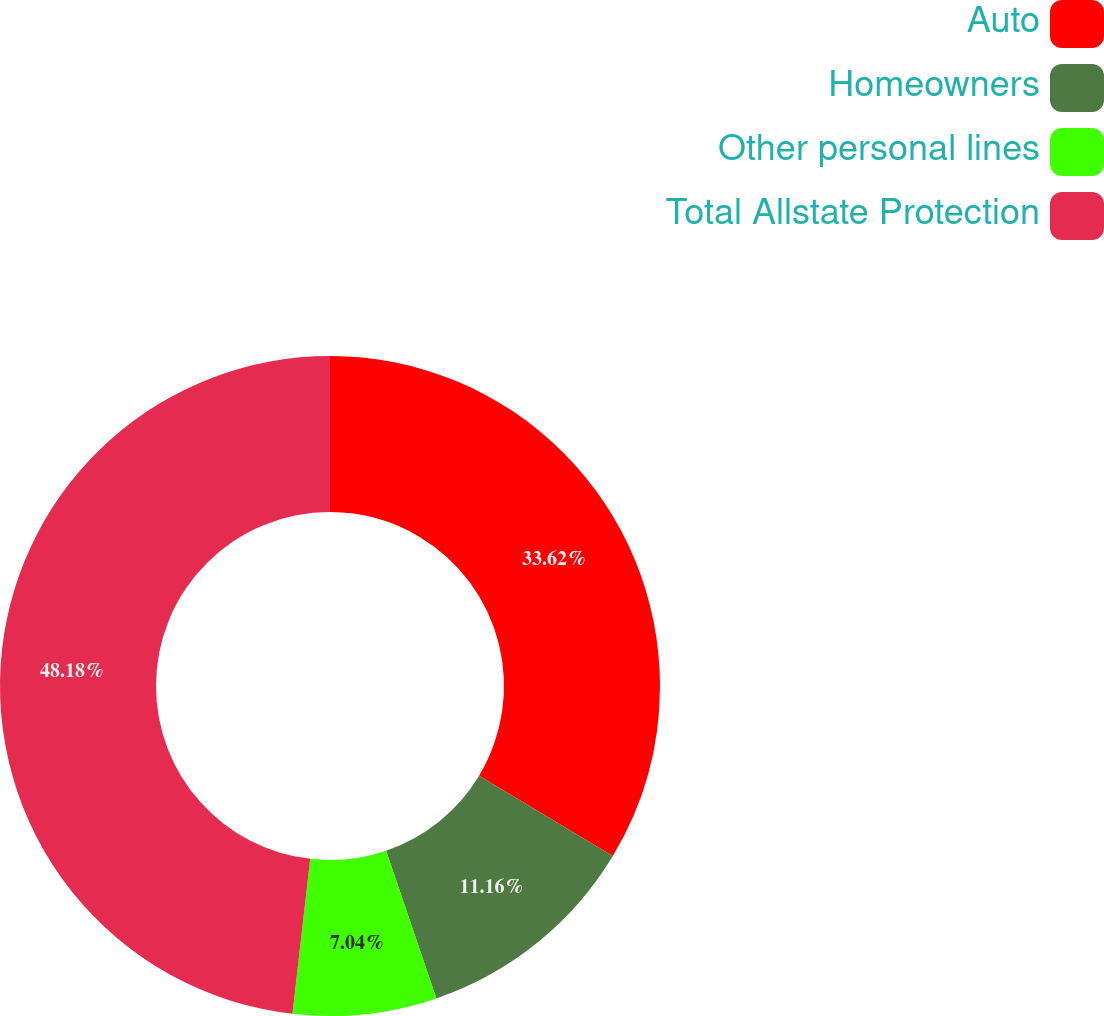<chart> <loc_0><loc_0><loc_500><loc_500><pie_chart><fcel>Auto<fcel>Homeowners<fcel>Other personal lines<fcel>Total Allstate Protection<nl><fcel>33.62%<fcel>11.16%<fcel>7.04%<fcel>48.19%<nl></chart> 